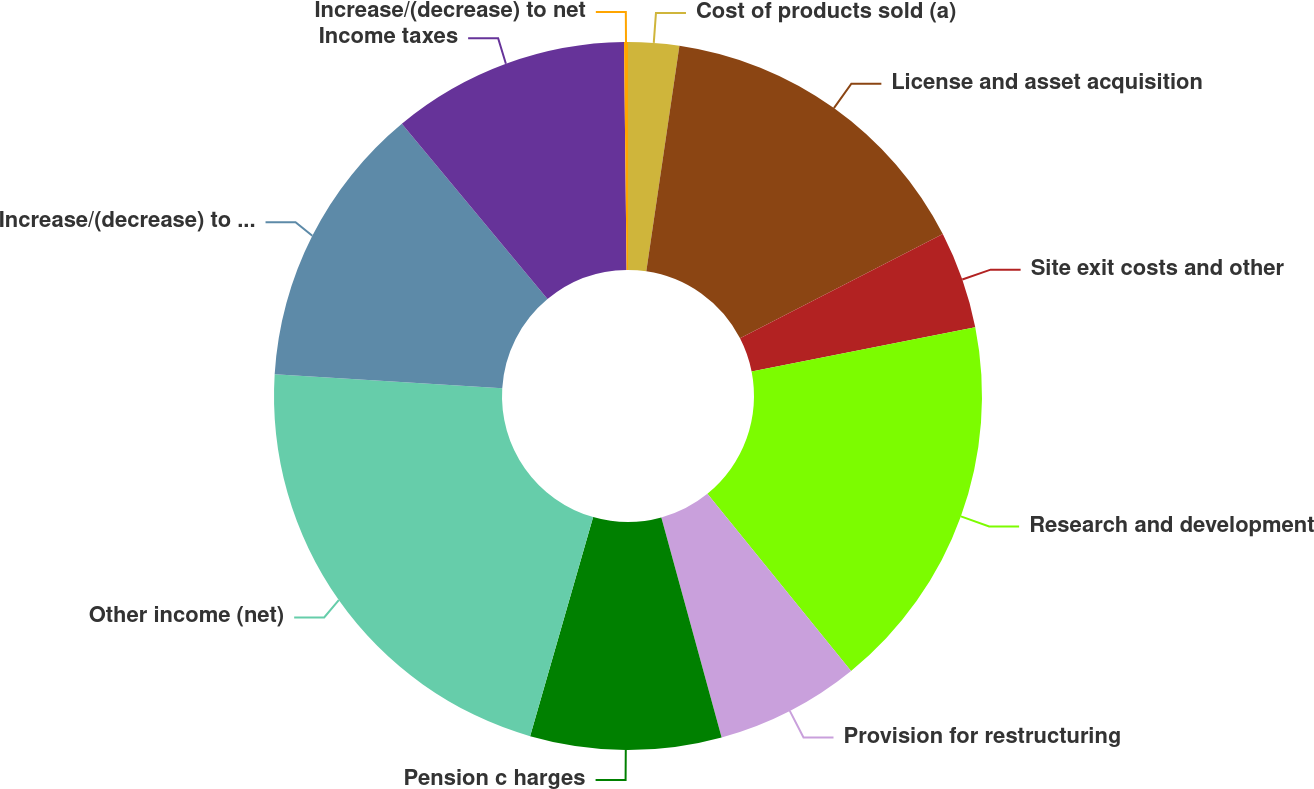<chart> <loc_0><loc_0><loc_500><loc_500><pie_chart><fcel>Cost of products sold (a)<fcel>License and asset acquisition<fcel>Site exit costs and other<fcel>Research and development<fcel>Provision for restructuring<fcel>Pension c harges<fcel>Other income (net)<fcel>Increase/(decrease) to pretax<fcel>Income taxes<fcel>Increase/(decrease) to net<nl><fcel>2.32%<fcel>15.12%<fcel>4.45%<fcel>17.26%<fcel>6.59%<fcel>8.72%<fcel>21.52%<fcel>12.99%<fcel>10.85%<fcel>0.18%<nl></chart> 